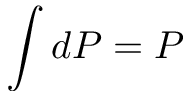Convert formula to latex. <formula><loc_0><loc_0><loc_500><loc_500>\int d P = P</formula> 